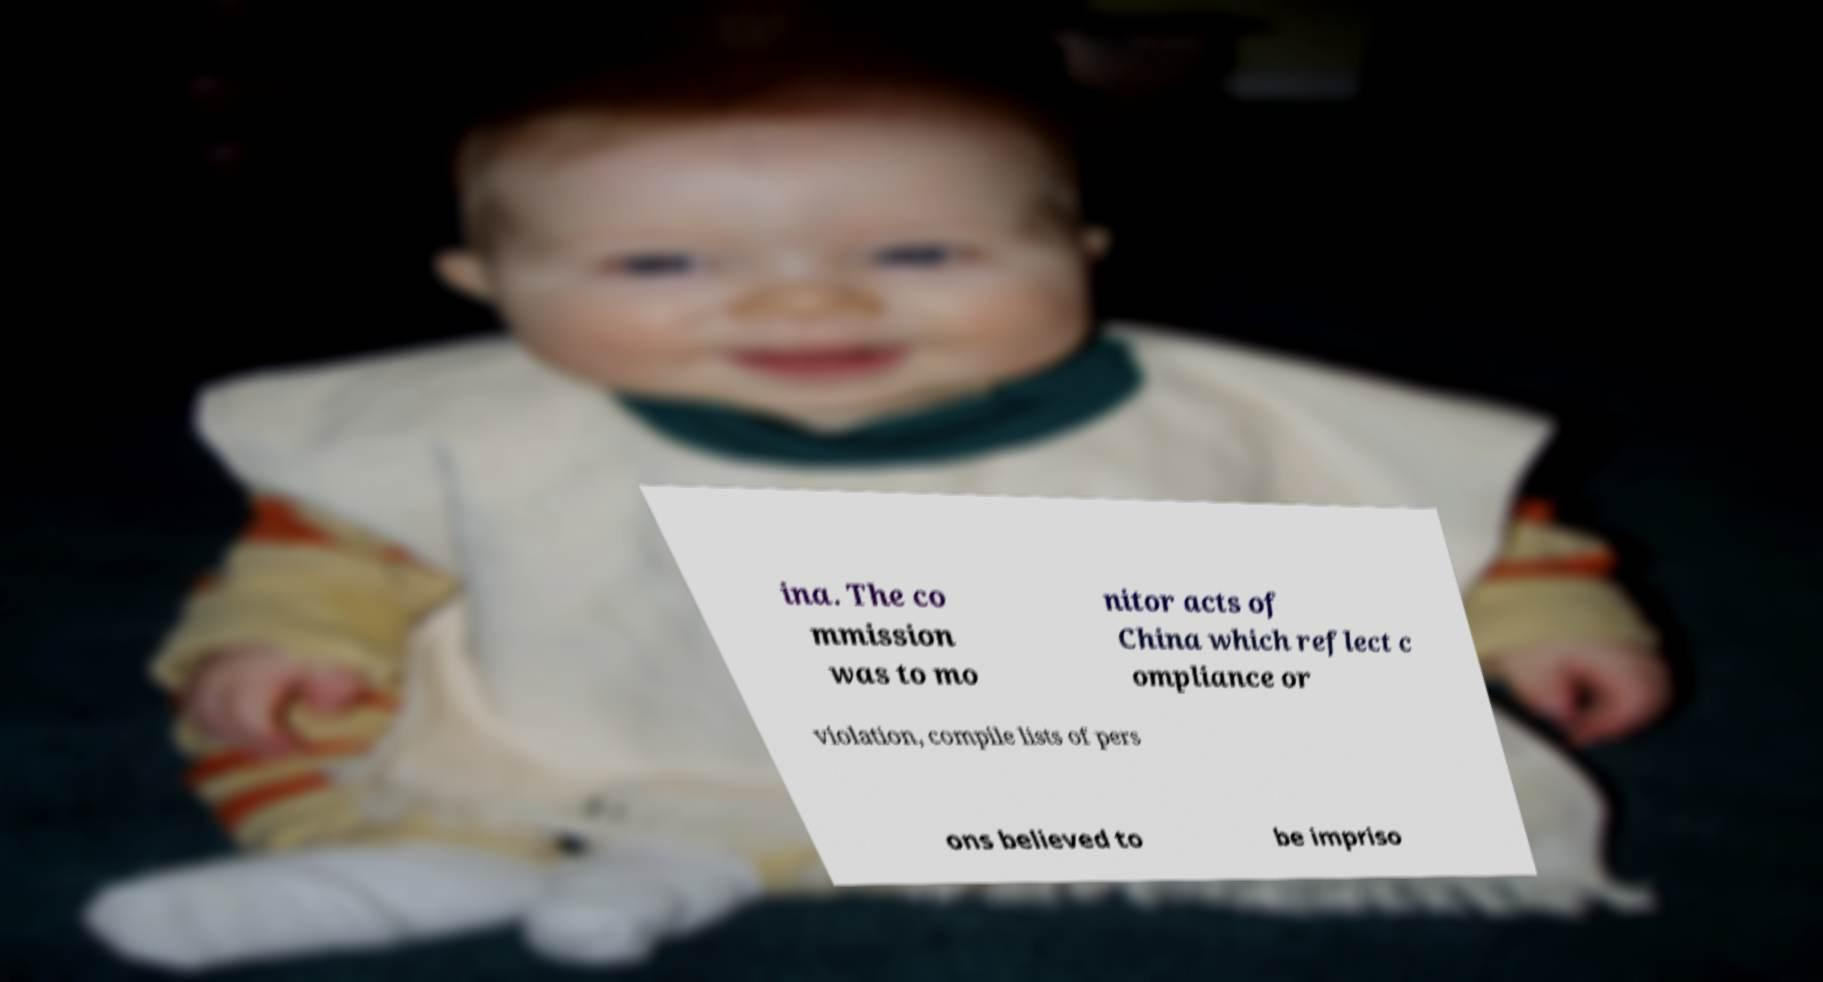For documentation purposes, I need the text within this image transcribed. Could you provide that? ina. The co mmission was to mo nitor acts of China which reflect c ompliance or violation, compile lists of pers ons believed to be impriso 